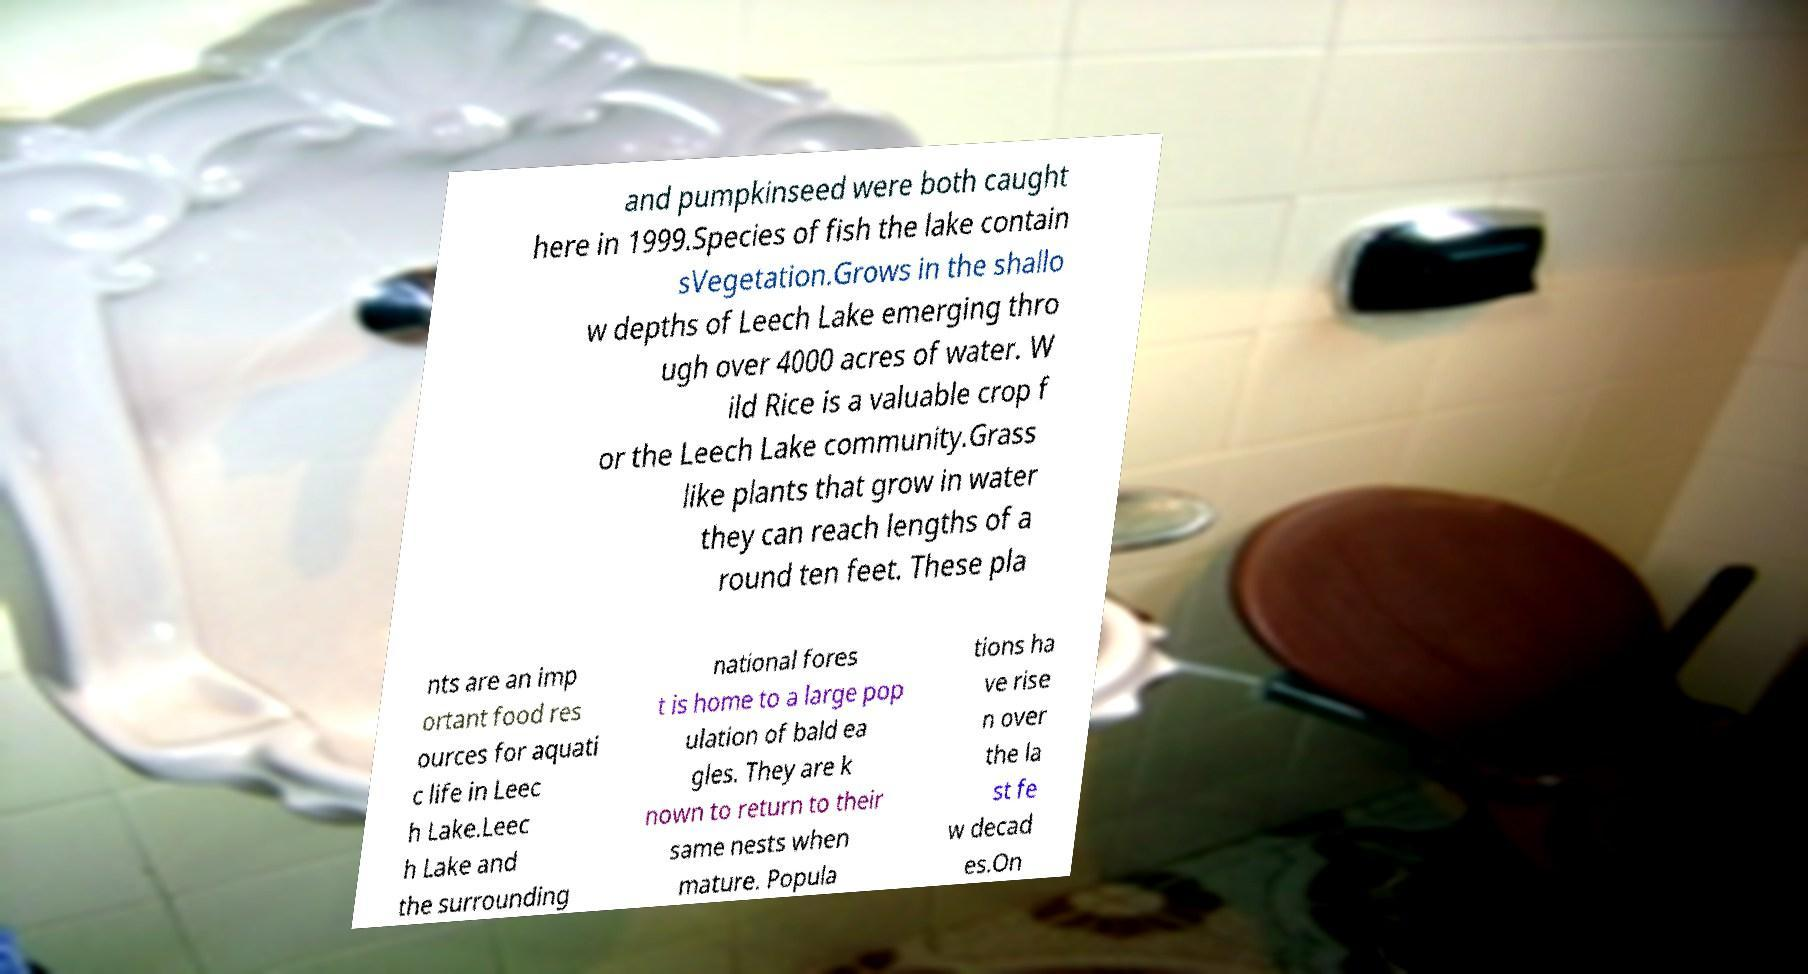Could you extract and type out the text from this image? and pumpkinseed were both caught here in 1999.Species of fish the lake contain sVegetation.Grows in the shallo w depths of Leech Lake emerging thro ugh over 4000 acres of water. W ild Rice is a valuable crop f or the Leech Lake community.Grass like plants that grow in water they can reach lengths of a round ten feet. These pla nts are an imp ortant food res ources for aquati c life in Leec h Lake.Leec h Lake and the surrounding national fores t is home to a large pop ulation of bald ea gles. They are k nown to return to their same nests when mature. Popula tions ha ve rise n over the la st fe w decad es.On 